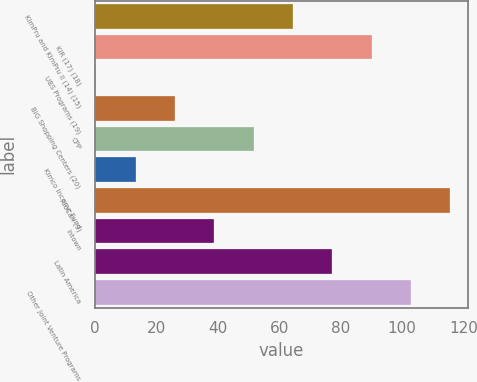<chart> <loc_0><loc_0><loc_500><loc_500><bar_chart><fcel>KimPru and KimPru II (14) (15)<fcel>KIR (17) (18)<fcel>UBS Programs (19)<fcel>BIG Shopping Centers (20)<fcel>CPP<fcel>Kimco Income Fund<fcel>RioCan (9)<fcel>Intown<fcel>Latin America<fcel>Other Joint Venture Programs<nl><fcel>64.5<fcel>90.1<fcel>0.5<fcel>26.1<fcel>51.7<fcel>13.3<fcel>115.7<fcel>38.9<fcel>77.3<fcel>102.9<nl></chart> 